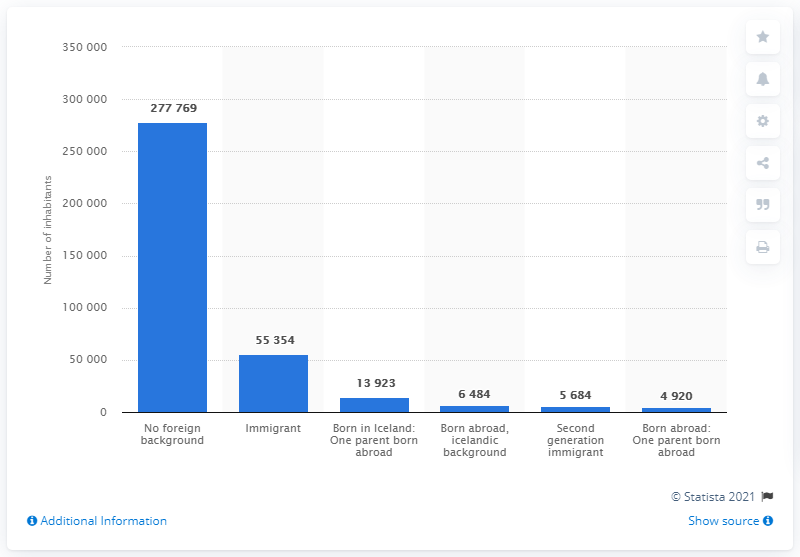Give some essential details in this illustration. In Iceland, 6,484 individuals born abroad had an Icelandic background, representing a significant portion of the country's population. In 2020, approximately 55,354 people in Iceland were immigrants, representing a significant portion of the country's population. In 2020, it is estimated that out of the approximately 364,000 individuals living in Iceland, approximately 277,769 had no foreign background. 